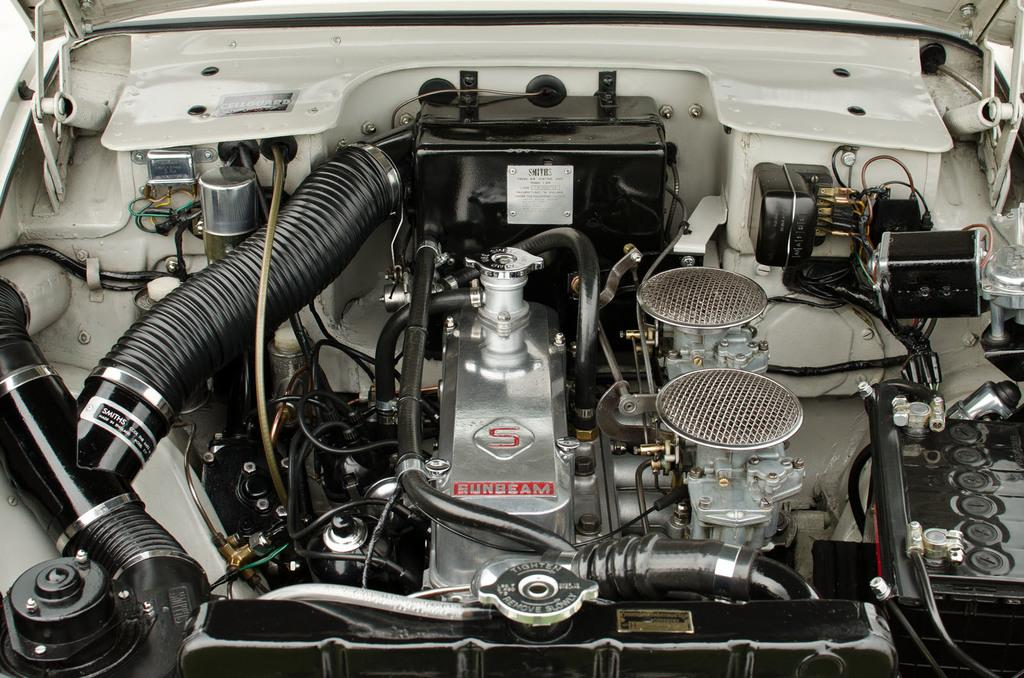What part of a car can be seen in the image? There is an engine of a car in the image. What type of components are visible in the image? There are pipes and cables in the image. What is the purpose of the radiator in the image? The radiator in the image has a lid, which suggests it is used for cooling the engine. What type of material is present in the image? There is a mesh in the image. What type of horse can be seen pulling a carriage in the image? There is no horse or carriage present in the image; it features an engine of a car and related components. What type of tin can be seen holding the engine in the image? There is no tin present in the image; it features an engine of a car and related components. 